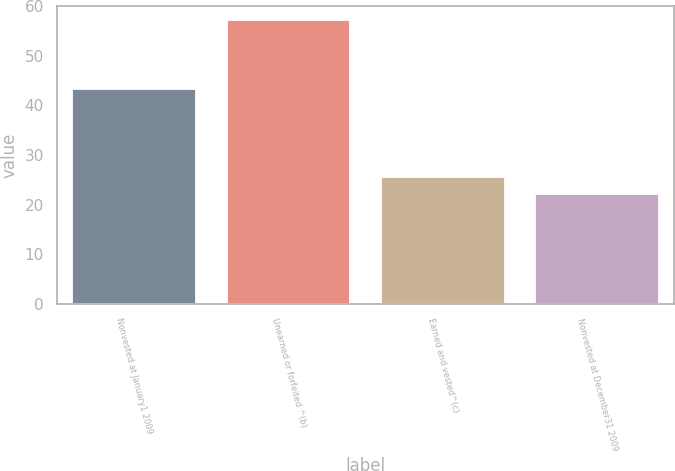Convert chart to OTSL. <chart><loc_0><loc_0><loc_500><loc_500><bar_chart><fcel>Nonvested at January1 2009<fcel>Unearned or forfeited ^(b)<fcel>Earned and vested^(c)<fcel>Nonvested at December31 2009<nl><fcel>43.28<fcel>57.15<fcel>25.66<fcel>22.07<nl></chart> 